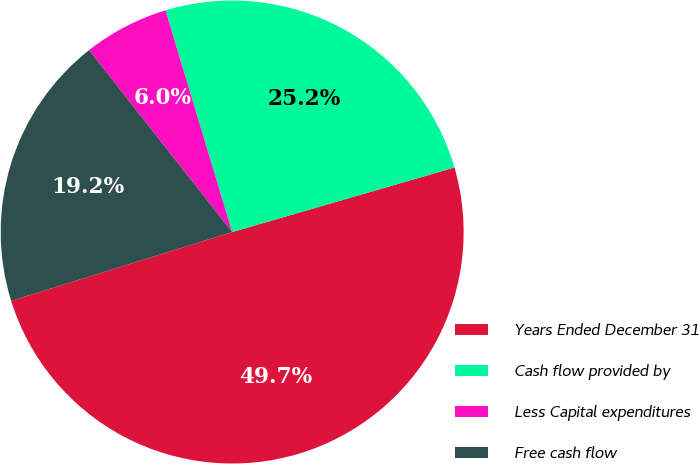Convert chart to OTSL. <chart><loc_0><loc_0><loc_500><loc_500><pie_chart><fcel>Years Ended December 31<fcel>Cash flow provided by<fcel>Less Capital expenditures<fcel>Free cash flow<nl><fcel>49.69%<fcel>25.15%<fcel>5.96%<fcel>19.2%<nl></chart> 